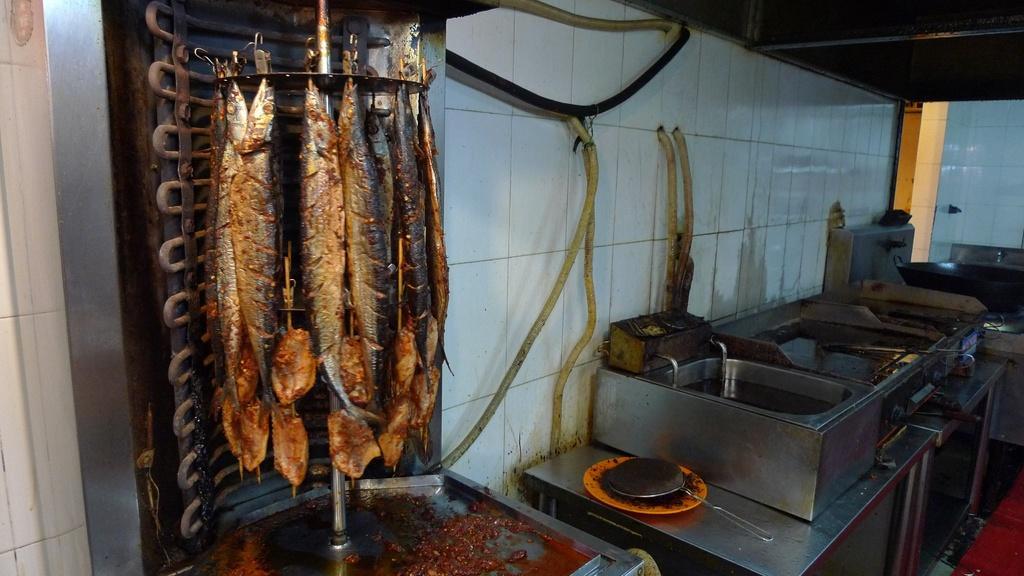Could you give a brief overview of what you see in this image? These are the fishes, on the right side there are iron boxes. 